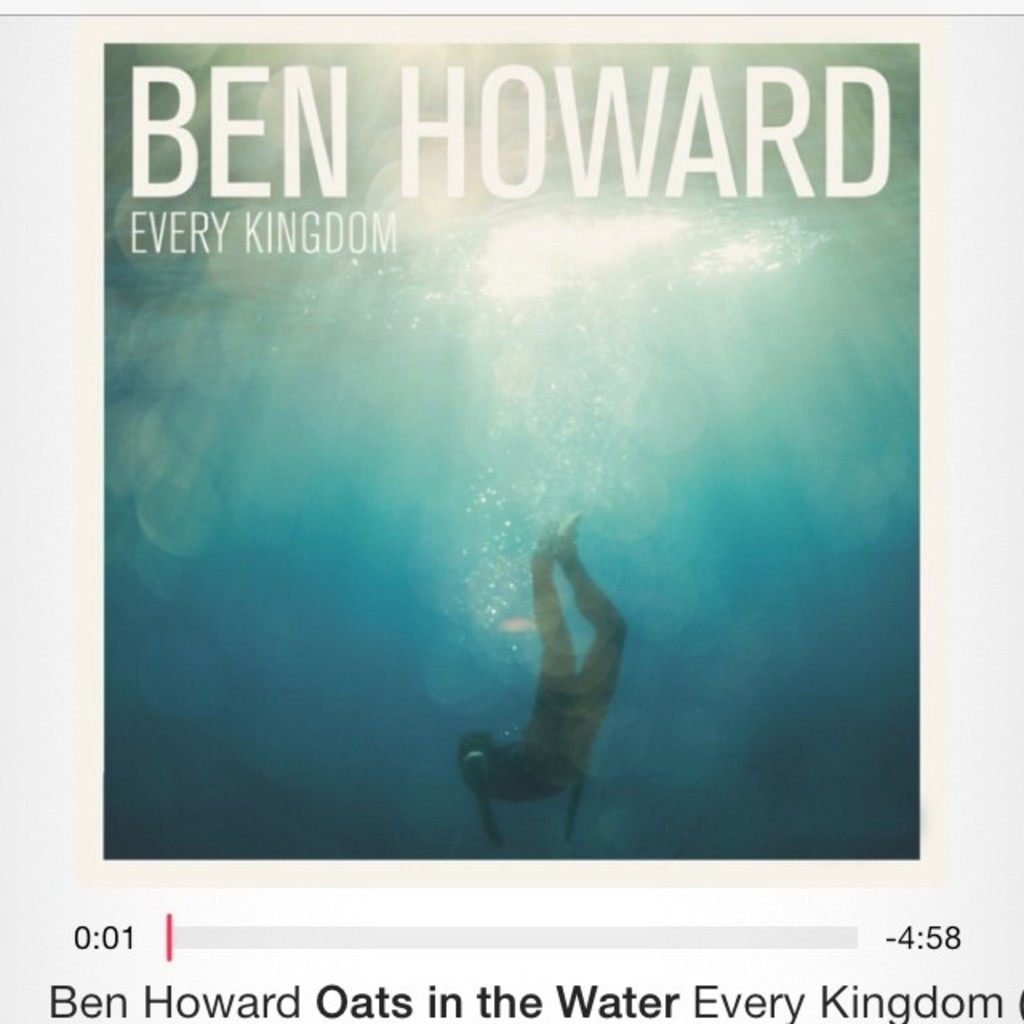What might the symbolism of the diver represent in relation to the album's themes? The image of the diver plunging into the deep waters can symbolize a journey of self-discovery and introspection, themes often prevalent in Ben Howard's music. It might also represent diving into the unknown or the depths of one's emotions, aligning with the introspective and often melancholic tone of the album 'Every Kingdom'. This visual metaphor enriches the listener's understanding of the album, suggesting a plunge into deep, reflective, and sometimes tumultuous waters of personal experience. 